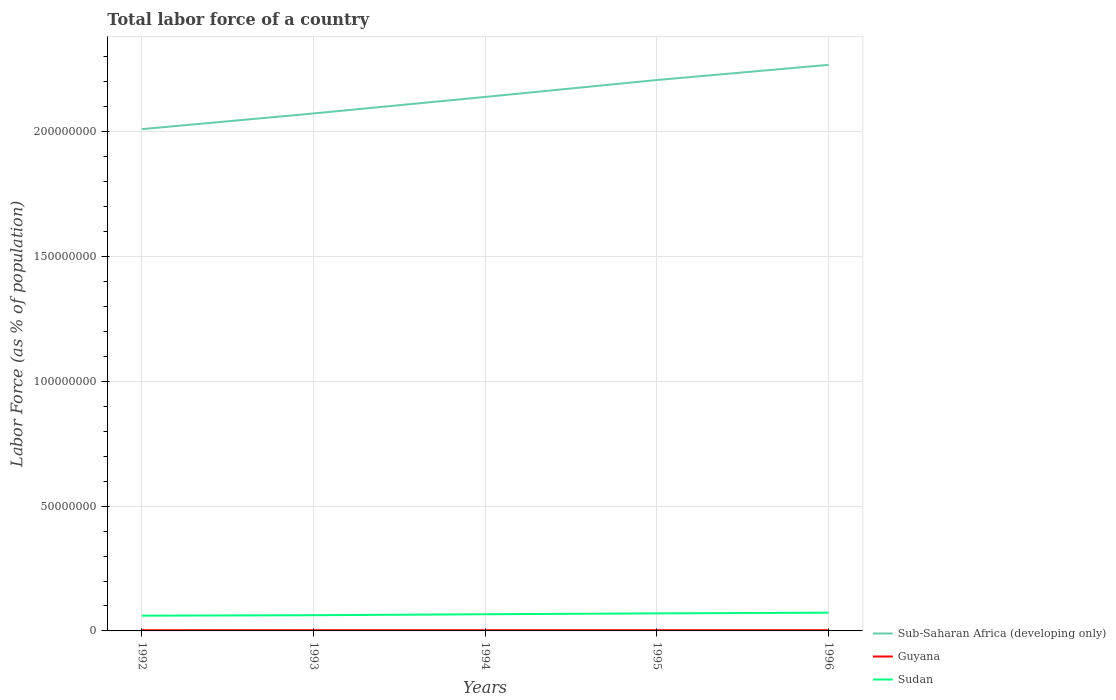How many different coloured lines are there?
Offer a terse response. 3. Across all years, what is the maximum percentage of labor force in Sub-Saharan Africa (developing only)?
Give a very brief answer. 2.01e+08. In which year was the percentage of labor force in Sudan maximum?
Provide a short and direct response. 1992. What is the total percentage of labor force in Sub-Saharan Africa (developing only) in the graph?
Your response must be concise. -1.95e+07. What is the difference between the highest and the second highest percentage of labor force in Sudan?
Keep it short and to the point. 1.20e+06. How many lines are there?
Keep it short and to the point. 3. How many years are there in the graph?
Give a very brief answer. 5. How many legend labels are there?
Make the answer very short. 3. How are the legend labels stacked?
Your answer should be compact. Vertical. What is the title of the graph?
Offer a terse response. Total labor force of a country. Does "Seychelles" appear as one of the legend labels in the graph?
Your answer should be compact. No. What is the label or title of the X-axis?
Make the answer very short. Years. What is the label or title of the Y-axis?
Provide a succinct answer. Labor Force (as % of population). What is the Labor Force (as % of population) of Sub-Saharan Africa (developing only) in 1992?
Your answer should be very brief. 2.01e+08. What is the Labor Force (as % of population) in Guyana in 1992?
Keep it short and to the point. 2.77e+05. What is the Labor Force (as % of population) of Sudan in 1992?
Provide a short and direct response. 6.11e+06. What is the Labor Force (as % of population) of Sub-Saharan Africa (developing only) in 1993?
Your response must be concise. 2.07e+08. What is the Labor Force (as % of population) of Guyana in 1993?
Give a very brief answer. 2.79e+05. What is the Labor Force (as % of population) in Sudan in 1993?
Provide a short and direct response. 6.30e+06. What is the Labor Force (as % of population) in Sub-Saharan Africa (developing only) in 1994?
Ensure brevity in your answer.  2.14e+08. What is the Labor Force (as % of population) in Guyana in 1994?
Your answer should be compact. 2.80e+05. What is the Labor Force (as % of population) in Sudan in 1994?
Offer a very short reply. 6.68e+06. What is the Labor Force (as % of population) in Sub-Saharan Africa (developing only) in 1995?
Offer a very short reply. 2.21e+08. What is the Labor Force (as % of population) of Guyana in 1995?
Give a very brief answer. 2.81e+05. What is the Labor Force (as % of population) of Sudan in 1995?
Offer a terse response. 7.03e+06. What is the Labor Force (as % of population) in Sub-Saharan Africa (developing only) in 1996?
Your answer should be very brief. 2.27e+08. What is the Labor Force (as % of population) in Guyana in 1996?
Your response must be concise. 2.84e+05. What is the Labor Force (as % of population) of Sudan in 1996?
Keep it short and to the point. 7.31e+06. Across all years, what is the maximum Labor Force (as % of population) of Sub-Saharan Africa (developing only)?
Give a very brief answer. 2.27e+08. Across all years, what is the maximum Labor Force (as % of population) in Guyana?
Ensure brevity in your answer.  2.84e+05. Across all years, what is the maximum Labor Force (as % of population) in Sudan?
Ensure brevity in your answer.  7.31e+06. Across all years, what is the minimum Labor Force (as % of population) in Sub-Saharan Africa (developing only)?
Your response must be concise. 2.01e+08. Across all years, what is the minimum Labor Force (as % of population) of Guyana?
Ensure brevity in your answer.  2.77e+05. Across all years, what is the minimum Labor Force (as % of population) of Sudan?
Ensure brevity in your answer.  6.11e+06. What is the total Labor Force (as % of population) in Sub-Saharan Africa (developing only) in the graph?
Give a very brief answer. 1.07e+09. What is the total Labor Force (as % of population) of Guyana in the graph?
Give a very brief answer. 1.40e+06. What is the total Labor Force (as % of population) in Sudan in the graph?
Give a very brief answer. 3.34e+07. What is the difference between the Labor Force (as % of population) in Sub-Saharan Africa (developing only) in 1992 and that in 1993?
Your response must be concise. -6.29e+06. What is the difference between the Labor Force (as % of population) of Guyana in 1992 and that in 1993?
Make the answer very short. -1958. What is the difference between the Labor Force (as % of population) in Sudan in 1992 and that in 1993?
Ensure brevity in your answer.  -1.89e+05. What is the difference between the Labor Force (as % of population) in Sub-Saharan Africa (developing only) in 1992 and that in 1994?
Your answer should be very brief. -1.29e+07. What is the difference between the Labor Force (as % of population) of Guyana in 1992 and that in 1994?
Your answer should be very brief. -2996. What is the difference between the Labor Force (as % of population) in Sudan in 1992 and that in 1994?
Your answer should be compact. -5.74e+05. What is the difference between the Labor Force (as % of population) in Sub-Saharan Africa (developing only) in 1992 and that in 1995?
Ensure brevity in your answer.  -1.97e+07. What is the difference between the Labor Force (as % of population) in Guyana in 1992 and that in 1995?
Make the answer very short. -4388. What is the difference between the Labor Force (as % of population) of Sudan in 1992 and that in 1995?
Provide a succinct answer. -9.26e+05. What is the difference between the Labor Force (as % of population) of Sub-Saharan Africa (developing only) in 1992 and that in 1996?
Provide a short and direct response. -2.58e+07. What is the difference between the Labor Force (as % of population) in Guyana in 1992 and that in 1996?
Your answer should be compact. -7811. What is the difference between the Labor Force (as % of population) of Sudan in 1992 and that in 1996?
Your answer should be very brief. -1.20e+06. What is the difference between the Labor Force (as % of population) in Sub-Saharan Africa (developing only) in 1993 and that in 1994?
Make the answer very short. -6.62e+06. What is the difference between the Labor Force (as % of population) of Guyana in 1993 and that in 1994?
Your answer should be compact. -1038. What is the difference between the Labor Force (as % of population) of Sudan in 1993 and that in 1994?
Your answer should be very brief. -3.85e+05. What is the difference between the Labor Force (as % of population) in Sub-Saharan Africa (developing only) in 1993 and that in 1995?
Keep it short and to the point. -1.34e+07. What is the difference between the Labor Force (as % of population) of Guyana in 1993 and that in 1995?
Give a very brief answer. -2430. What is the difference between the Labor Force (as % of population) of Sudan in 1993 and that in 1995?
Give a very brief answer. -7.37e+05. What is the difference between the Labor Force (as % of population) in Sub-Saharan Africa (developing only) in 1993 and that in 1996?
Offer a very short reply. -1.95e+07. What is the difference between the Labor Force (as % of population) in Guyana in 1993 and that in 1996?
Your answer should be very brief. -5853. What is the difference between the Labor Force (as % of population) in Sudan in 1993 and that in 1996?
Provide a succinct answer. -1.01e+06. What is the difference between the Labor Force (as % of population) of Sub-Saharan Africa (developing only) in 1994 and that in 1995?
Provide a short and direct response. -6.78e+06. What is the difference between the Labor Force (as % of population) in Guyana in 1994 and that in 1995?
Offer a very short reply. -1392. What is the difference between the Labor Force (as % of population) in Sudan in 1994 and that in 1995?
Your answer should be very brief. -3.52e+05. What is the difference between the Labor Force (as % of population) of Sub-Saharan Africa (developing only) in 1994 and that in 1996?
Your answer should be very brief. -1.29e+07. What is the difference between the Labor Force (as % of population) in Guyana in 1994 and that in 1996?
Provide a short and direct response. -4815. What is the difference between the Labor Force (as % of population) in Sudan in 1994 and that in 1996?
Give a very brief answer. -6.26e+05. What is the difference between the Labor Force (as % of population) of Sub-Saharan Africa (developing only) in 1995 and that in 1996?
Keep it short and to the point. -6.08e+06. What is the difference between the Labor Force (as % of population) in Guyana in 1995 and that in 1996?
Provide a short and direct response. -3423. What is the difference between the Labor Force (as % of population) in Sudan in 1995 and that in 1996?
Your answer should be compact. -2.74e+05. What is the difference between the Labor Force (as % of population) in Sub-Saharan Africa (developing only) in 1992 and the Labor Force (as % of population) in Guyana in 1993?
Provide a succinct answer. 2.01e+08. What is the difference between the Labor Force (as % of population) of Sub-Saharan Africa (developing only) in 1992 and the Labor Force (as % of population) of Sudan in 1993?
Ensure brevity in your answer.  1.95e+08. What is the difference between the Labor Force (as % of population) of Guyana in 1992 and the Labor Force (as % of population) of Sudan in 1993?
Keep it short and to the point. -6.02e+06. What is the difference between the Labor Force (as % of population) of Sub-Saharan Africa (developing only) in 1992 and the Labor Force (as % of population) of Guyana in 1994?
Give a very brief answer. 2.01e+08. What is the difference between the Labor Force (as % of population) of Sub-Saharan Africa (developing only) in 1992 and the Labor Force (as % of population) of Sudan in 1994?
Provide a succinct answer. 1.94e+08. What is the difference between the Labor Force (as % of population) of Guyana in 1992 and the Labor Force (as % of population) of Sudan in 1994?
Keep it short and to the point. -6.41e+06. What is the difference between the Labor Force (as % of population) of Sub-Saharan Africa (developing only) in 1992 and the Labor Force (as % of population) of Guyana in 1995?
Ensure brevity in your answer.  2.01e+08. What is the difference between the Labor Force (as % of population) of Sub-Saharan Africa (developing only) in 1992 and the Labor Force (as % of population) of Sudan in 1995?
Your response must be concise. 1.94e+08. What is the difference between the Labor Force (as % of population) in Guyana in 1992 and the Labor Force (as % of population) in Sudan in 1995?
Make the answer very short. -6.76e+06. What is the difference between the Labor Force (as % of population) of Sub-Saharan Africa (developing only) in 1992 and the Labor Force (as % of population) of Guyana in 1996?
Offer a terse response. 2.01e+08. What is the difference between the Labor Force (as % of population) in Sub-Saharan Africa (developing only) in 1992 and the Labor Force (as % of population) in Sudan in 1996?
Your answer should be compact. 1.94e+08. What is the difference between the Labor Force (as % of population) of Guyana in 1992 and the Labor Force (as % of population) of Sudan in 1996?
Ensure brevity in your answer.  -7.03e+06. What is the difference between the Labor Force (as % of population) of Sub-Saharan Africa (developing only) in 1993 and the Labor Force (as % of population) of Guyana in 1994?
Provide a short and direct response. 2.07e+08. What is the difference between the Labor Force (as % of population) in Sub-Saharan Africa (developing only) in 1993 and the Labor Force (as % of population) in Sudan in 1994?
Provide a succinct answer. 2.01e+08. What is the difference between the Labor Force (as % of population) of Guyana in 1993 and the Labor Force (as % of population) of Sudan in 1994?
Provide a succinct answer. -6.40e+06. What is the difference between the Labor Force (as % of population) of Sub-Saharan Africa (developing only) in 1993 and the Labor Force (as % of population) of Guyana in 1995?
Offer a very short reply. 2.07e+08. What is the difference between the Labor Force (as % of population) of Sub-Saharan Africa (developing only) in 1993 and the Labor Force (as % of population) of Sudan in 1995?
Keep it short and to the point. 2.00e+08. What is the difference between the Labor Force (as % of population) of Guyana in 1993 and the Labor Force (as % of population) of Sudan in 1995?
Offer a very short reply. -6.76e+06. What is the difference between the Labor Force (as % of population) in Sub-Saharan Africa (developing only) in 1993 and the Labor Force (as % of population) in Guyana in 1996?
Your answer should be compact. 2.07e+08. What is the difference between the Labor Force (as % of population) in Sub-Saharan Africa (developing only) in 1993 and the Labor Force (as % of population) in Sudan in 1996?
Your answer should be compact. 2.00e+08. What is the difference between the Labor Force (as % of population) in Guyana in 1993 and the Labor Force (as % of population) in Sudan in 1996?
Give a very brief answer. -7.03e+06. What is the difference between the Labor Force (as % of population) in Sub-Saharan Africa (developing only) in 1994 and the Labor Force (as % of population) in Guyana in 1995?
Give a very brief answer. 2.14e+08. What is the difference between the Labor Force (as % of population) of Sub-Saharan Africa (developing only) in 1994 and the Labor Force (as % of population) of Sudan in 1995?
Give a very brief answer. 2.07e+08. What is the difference between the Labor Force (as % of population) of Guyana in 1994 and the Labor Force (as % of population) of Sudan in 1995?
Provide a succinct answer. -6.75e+06. What is the difference between the Labor Force (as % of population) in Sub-Saharan Africa (developing only) in 1994 and the Labor Force (as % of population) in Guyana in 1996?
Your answer should be compact. 2.14e+08. What is the difference between the Labor Force (as % of population) of Sub-Saharan Africa (developing only) in 1994 and the Labor Force (as % of population) of Sudan in 1996?
Give a very brief answer. 2.07e+08. What is the difference between the Labor Force (as % of population) of Guyana in 1994 and the Labor Force (as % of population) of Sudan in 1996?
Make the answer very short. -7.03e+06. What is the difference between the Labor Force (as % of population) in Sub-Saharan Africa (developing only) in 1995 and the Labor Force (as % of population) in Guyana in 1996?
Provide a succinct answer. 2.20e+08. What is the difference between the Labor Force (as % of population) of Sub-Saharan Africa (developing only) in 1995 and the Labor Force (as % of population) of Sudan in 1996?
Offer a terse response. 2.13e+08. What is the difference between the Labor Force (as % of population) of Guyana in 1995 and the Labor Force (as % of population) of Sudan in 1996?
Your answer should be compact. -7.03e+06. What is the average Labor Force (as % of population) of Sub-Saharan Africa (developing only) per year?
Make the answer very short. 2.14e+08. What is the average Labor Force (as % of population) in Guyana per year?
Give a very brief answer. 2.80e+05. What is the average Labor Force (as % of population) of Sudan per year?
Ensure brevity in your answer.  6.69e+06. In the year 1992, what is the difference between the Labor Force (as % of population) in Sub-Saharan Africa (developing only) and Labor Force (as % of population) in Guyana?
Your response must be concise. 2.01e+08. In the year 1992, what is the difference between the Labor Force (as % of population) in Sub-Saharan Africa (developing only) and Labor Force (as % of population) in Sudan?
Provide a short and direct response. 1.95e+08. In the year 1992, what is the difference between the Labor Force (as % of population) of Guyana and Labor Force (as % of population) of Sudan?
Ensure brevity in your answer.  -5.83e+06. In the year 1993, what is the difference between the Labor Force (as % of population) in Sub-Saharan Africa (developing only) and Labor Force (as % of population) in Guyana?
Your response must be concise. 2.07e+08. In the year 1993, what is the difference between the Labor Force (as % of population) in Sub-Saharan Africa (developing only) and Labor Force (as % of population) in Sudan?
Your response must be concise. 2.01e+08. In the year 1993, what is the difference between the Labor Force (as % of population) of Guyana and Labor Force (as % of population) of Sudan?
Your answer should be compact. -6.02e+06. In the year 1994, what is the difference between the Labor Force (as % of population) of Sub-Saharan Africa (developing only) and Labor Force (as % of population) of Guyana?
Offer a terse response. 2.14e+08. In the year 1994, what is the difference between the Labor Force (as % of population) in Sub-Saharan Africa (developing only) and Labor Force (as % of population) in Sudan?
Provide a succinct answer. 2.07e+08. In the year 1994, what is the difference between the Labor Force (as % of population) of Guyana and Labor Force (as % of population) of Sudan?
Keep it short and to the point. -6.40e+06. In the year 1995, what is the difference between the Labor Force (as % of population) of Sub-Saharan Africa (developing only) and Labor Force (as % of population) of Guyana?
Provide a succinct answer. 2.20e+08. In the year 1995, what is the difference between the Labor Force (as % of population) of Sub-Saharan Africa (developing only) and Labor Force (as % of population) of Sudan?
Offer a very short reply. 2.14e+08. In the year 1995, what is the difference between the Labor Force (as % of population) of Guyana and Labor Force (as % of population) of Sudan?
Offer a very short reply. -6.75e+06. In the year 1996, what is the difference between the Labor Force (as % of population) in Sub-Saharan Africa (developing only) and Labor Force (as % of population) in Guyana?
Your answer should be compact. 2.27e+08. In the year 1996, what is the difference between the Labor Force (as % of population) of Sub-Saharan Africa (developing only) and Labor Force (as % of population) of Sudan?
Ensure brevity in your answer.  2.20e+08. In the year 1996, what is the difference between the Labor Force (as % of population) of Guyana and Labor Force (as % of population) of Sudan?
Your answer should be very brief. -7.02e+06. What is the ratio of the Labor Force (as % of population) of Sub-Saharan Africa (developing only) in 1992 to that in 1993?
Provide a succinct answer. 0.97. What is the ratio of the Labor Force (as % of population) of Sub-Saharan Africa (developing only) in 1992 to that in 1994?
Offer a very short reply. 0.94. What is the ratio of the Labor Force (as % of population) of Guyana in 1992 to that in 1994?
Give a very brief answer. 0.99. What is the ratio of the Labor Force (as % of population) in Sudan in 1992 to that in 1994?
Offer a very short reply. 0.91. What is the ratio of the Labor Force (as % of population) in Sub-Saharan Africa (developing only) in 1992 to that in 1995?
Provide a succinct answer. 0.91. What is the ratio of the Labor Force (as % of population) in Guyana in 1992 to that in 1995?
Your response must be concise. 0.98. What is the ratio of the Labor Force (as % of population) of Sudan in 1992 to that in 1995?
Provide a short and direct response. 0.87. What is the ratio of the Labor Force (as % of population) of Sub-Saharan Africa (developing only) in 1992 to that in 1996?
Provide a succinct answer. 0.89. What is the ratio of the Labor Force (as % of population) of Guyana in 1992 to that in 1996?
Make the answer very short. 0.97. What is the ratio of the Labor Force (as % of population) of Sudan in 1992 to that in 1996?
Provide a short and direct response. 0.84. What is the ratio of the Labor Force (as % of population) in Sub-Saharan Africa (developing only) in 1993 to that in 1994?
Provide a succinct answer. 0.97. What is the ratio of the Labor Force (as % of population) of Sudan in 1993 to that in 1994?
Offer a terse response. 0.94. What is the ratio of the Labor Force (as % of population) of Sub-Saharan Africa (developing only) in 1993 to that in 1995?
Offer a very short reply. 0.94. What is the ratio of the Labor Force (as % of population) in Sudan in 1993 to that in 1995?
Provide a short and direct response. 0.9. What is the ratio of the Labor Force (as % of population) of Sub-Saharan Africa (developing only) in 1993 to that in 1996?
Give a very brief answer. 0.91. What is the ratio of the Labor Force (as % of population) of Guyana in 1993 to that in 1996?
Ensure brevity in your answer.  0.98. What is the ratio of the Labor Force (as % of population) in Sudan in 1993 to that in 1996?
Your answer should be compact. 0.86. What is the ratio of the Labor Force (as % of population) in Sub-Saharan Africa (developing only) in 1994 to that in 1995?
Provide a short and direct response. 0.97. What is the ratio of the Labor Force (as % of population) of Guyana in 1994 to that in 1995?
Give a very brief answer. 0.99. What is the ratio of the Labor Force (as % of population) in Sub-Saharan Africa (developing only) in 1994 to that in 1996?
Your response must be concise. 0.94. What is the ratio of the Labor Force (as % of population) of Guyana in 1994 to that in 1996?
Your answer should be compact. 0.98. What is the ratio of the Labor Force (as % of population) in Sudan in 1994 to that in 1996?
Keep it short and to the point. 0.91. What is the ratio of the Labor Force (as % of population) of Sub-Saharan Africa (developing only) in 1995 to that in 1996?
Make the answer very short. 0.97. What is the ratio of the Labor Force (as % of population) in Guyana in 1995 to that in 1996?
Provide a succinct answer. 0.99. What is the ratio of the Labor Force (as % of population) in Sudan in 1995 to that in 1996?
Make the answer very short. 0.96. What is the difference between the highest and the second highest Labor Force (as % of population) in Sub-Saharan Africa (developing only)?
Your answer should be very brief. 6.08e+06. What is the difference between the highest and the second highest Labor Force (as % of population) of Guyana?
Keep it short and to the point. 3423. What is the difference between the highest and the second highest Labor Force (as % of population) of Sudan?
Ensure brevity in your answer.  2.74e+05. What is the difference between the highest and the lowest Labor Force (as % of population) in Sub-Saharan Africa (developing only)?
Your response must be concise. 2.58e+07. What is the difference between the highest and the lowest Labor Force (as % of population) of Guyana?
Your answer should be compact. 7811. What is the difference between the highest and the lowest Labor Force (as % of population) in Sudan?
Provide a succinct answer. 1.20e+06. 